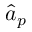Convert formula to latex. <formula><loc_0><loc_0><loc_500><loc_500>\hat { a } _ { p }</formula> 